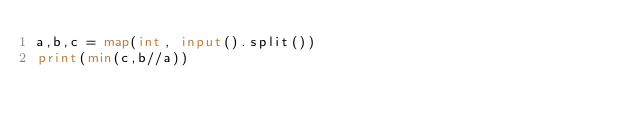Convert code to text. <code><loc_0><loc_0><loc_500><loc_500><_Python_>a,b,c = map(int, input().split())
print(min(c,b//a))</code> 